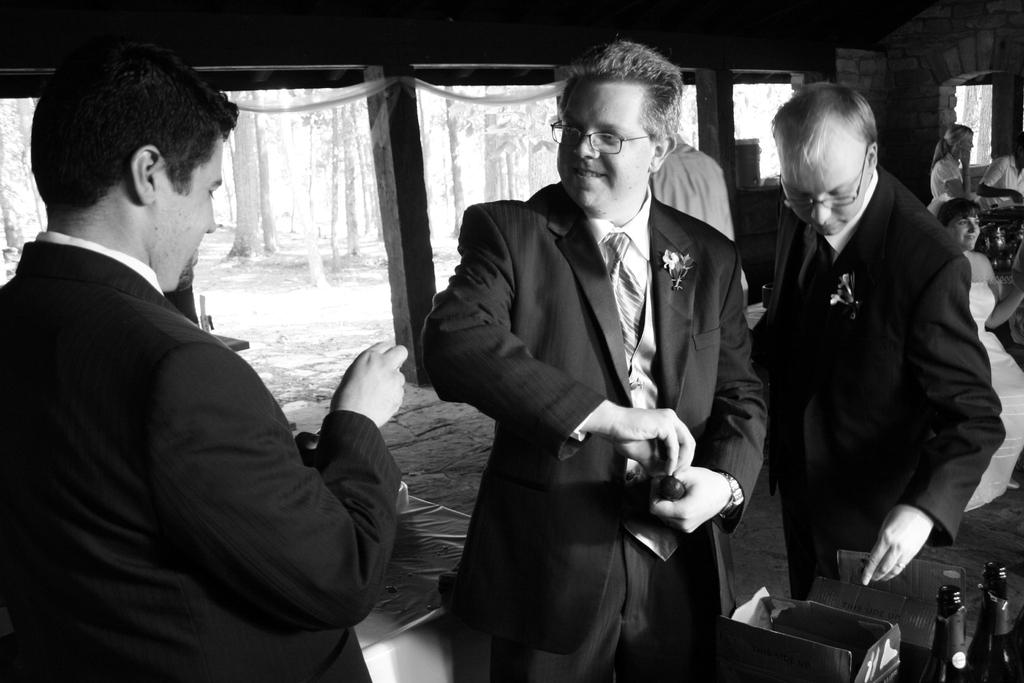What is the man in the image wearing? The man in the image is wearing a black coat. What is the man holding in his hand? The man is holding something in his hand, but we cannot determine what it is from the image. How many men are watching the first man? There are two men watching the first man. What can be seen in the background of the image? Tree trunks are visible in the background of the image. What type of fork is the writer using to eat in the image? There is no writer or fork present in the image. 